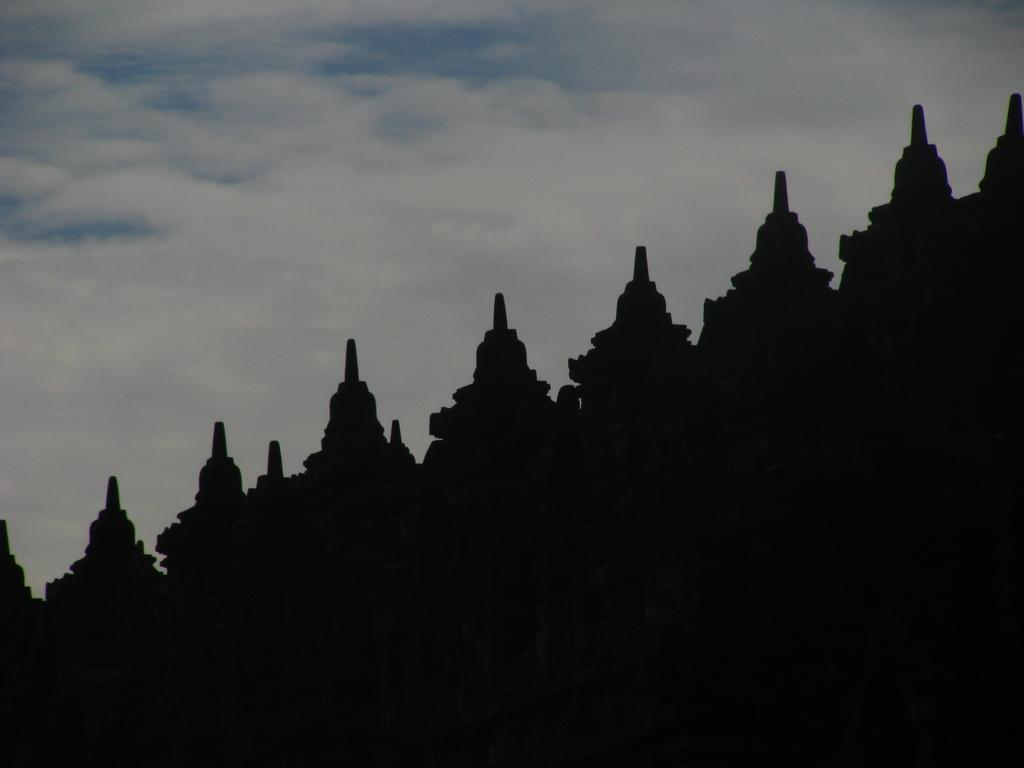What type of structure is present in the image? There is a building in the image, and it has a structure that resembles a temple. What can be seen at the top of the image? The sky is visible at the top of the image. What type of attack is being carried out on the building in the image? There is no attack present in the image; it simply shows a building with a temple-like structure. Can you see a guitar being played in the image? There is no guitar present in the image. 